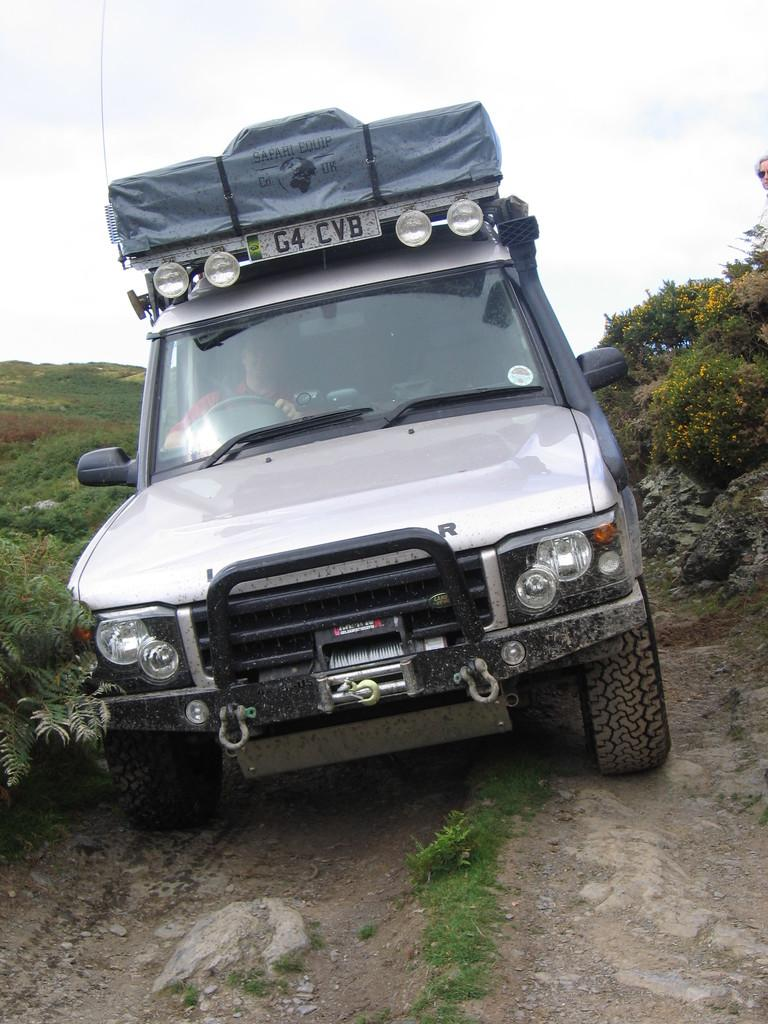What is parked on the ground in the image? There is a car parked on the ground in the image. What is the surface of the ground like? The ground is covered with grass. What can be seen on both sides of the car? There are plants on both sides of the car. Who or what is inside the car? There are people sitting in the car. What type of question is being asked by the car in the image? There is no indication in the image that the car is asking any questions. 